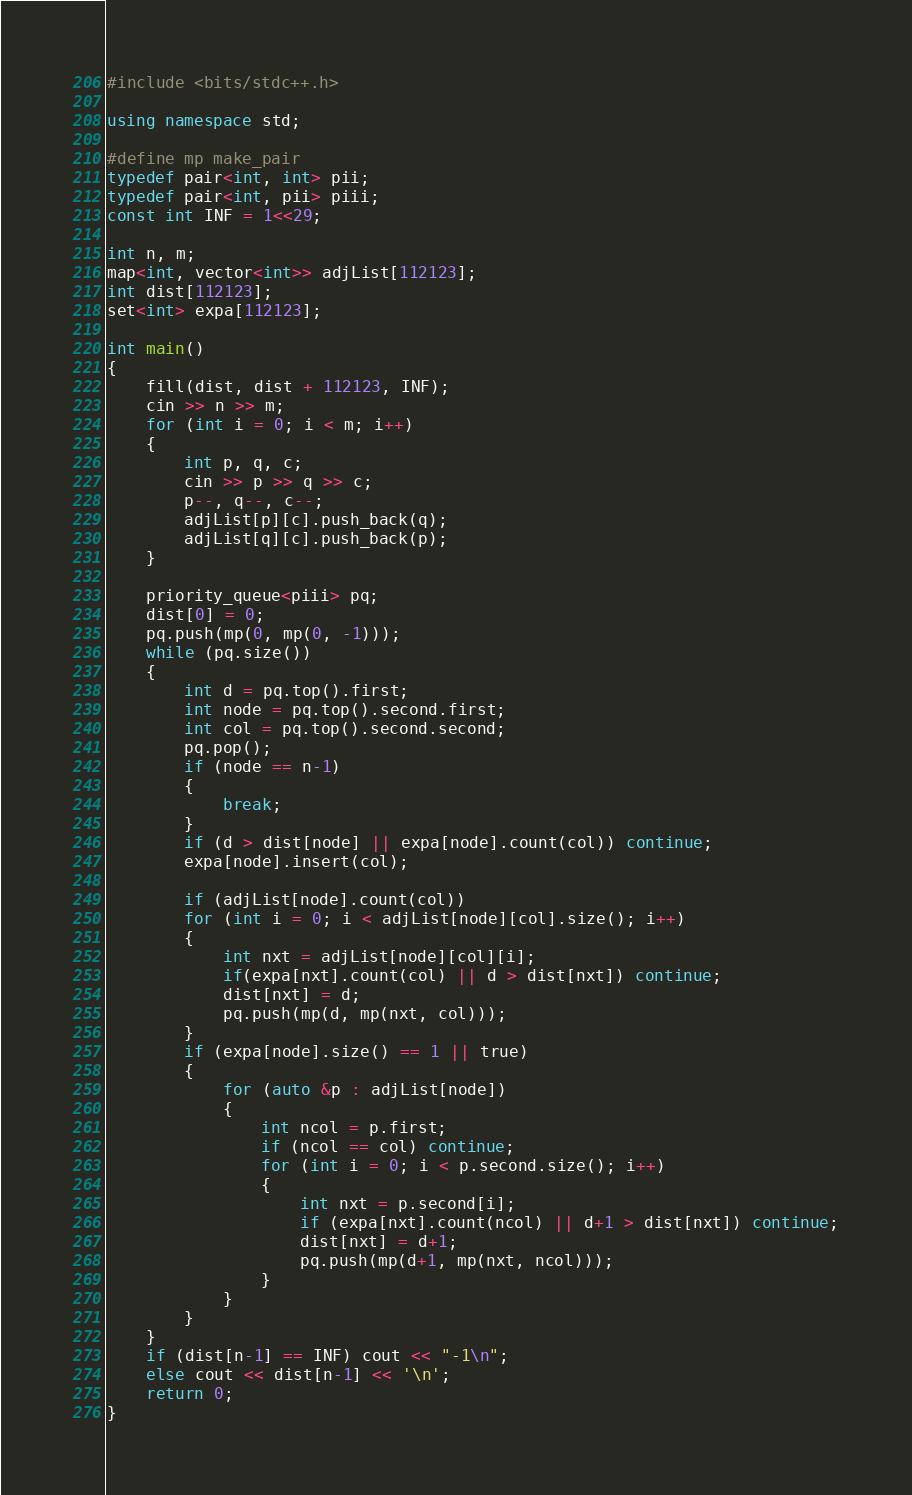<code> <loc_0><loc_0><loc_500><loc_500><_C++_>#include <bits/stdc++.h>

using namespace std;

#define mp make_pair
typedef pair<int, int> pii;
typedef pair<int, pii> piii;
const int INF = 1<<29;

int n, m;
map<int, vector<int>> adjList[112123];
int dist[112123];
set<int> expa[112123];

int main()
{
	fill(dist, dist + 112123, INF);
	cin >> n >> m;
	for (int i = 0; i < m; i++)
	{
		int p, q, c;
		cin >> p >> q >> c;
		p--, q--, c--;
		adjList[p][c].push_back(q);
		adjList[q][c].push_back(p);
	}

	priority_queue<piii> pq;
	dist[0] = 0;
	pq.push(mp(0, mp(0, -1)));
	while (pq.size())
	{
		int d = pq.top().first;
		int node = pq.top().second.first;
		int col = pq.top().second.second;
		pq.pop();
		if (node == n-1)
		{
			break;
		}
		if (d > dist[node] || expa[node].count(col)) continue;
		expa[node].insert(col);

		if (adjList[node].count(col))
		for (int i = 0; i < adjList[node][col].size(); i++)
		{
			int nxt = adjList[node][col][i];
			if(expa[nxt].count(col) || d > dist[nxt]) continue;
			dist[nxt] = d;
			pq.push(mp(d, mp(nxt, col)));
		}
		if (expa[node].size() == 1 || true)
		{
			for (auto &p : adjList[node])
			{
				int ncol = p.first;
				if (ncol == col) continue;
				for (int i = 0; i < p.second.size(); i++)
				{
					int nxt = p.second[i];
					if (expa[nxt].count(ncol) || d+1 > dist[nxt]) continue;
					dist[nxt] = d+1;
					pq.push(mp(d+1, mp(nxt, ncol)));
				}
			}
		}
	}
	if (dist[n-1] == INF) cout << "-1\n";
	else cout << dist[n-1] << '\n';
	return 0;
}

</code> 